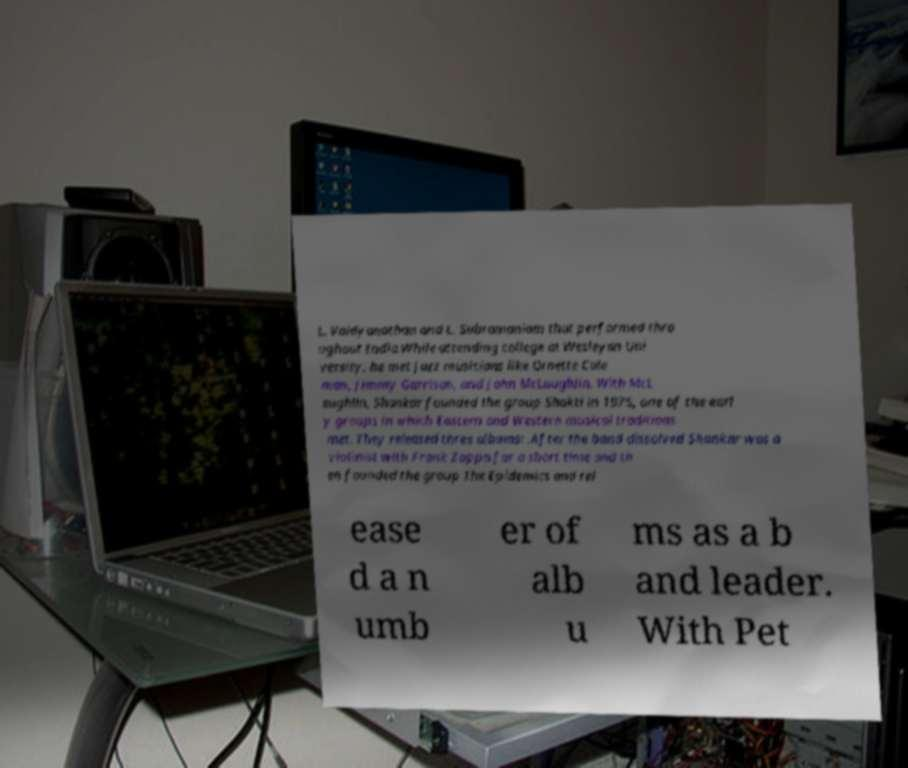Can you read and provide the text displayed in the image?This photo seems to have some interesting text. Can you extract and type it out for me? L. Vaidyanathan and L. Subramaniam that performed thro ughout India.While attending college at Wesleyan Uni versity, he met jazz musicians like Ornette Cole man, Jimmy Garrison, and John McLaughlin. With McL aughlin, Shankar founded the group Shakti in 1975, one of the earl y groups in which Eastern and Western musical traditions met. They released three albums: .After the band dissolved Shankar was a violinist with Frank Zappa for a short time and th en founded the group The Epidemics and rel ease d a n umb er of alb u ms as a b and leader. With Pet 